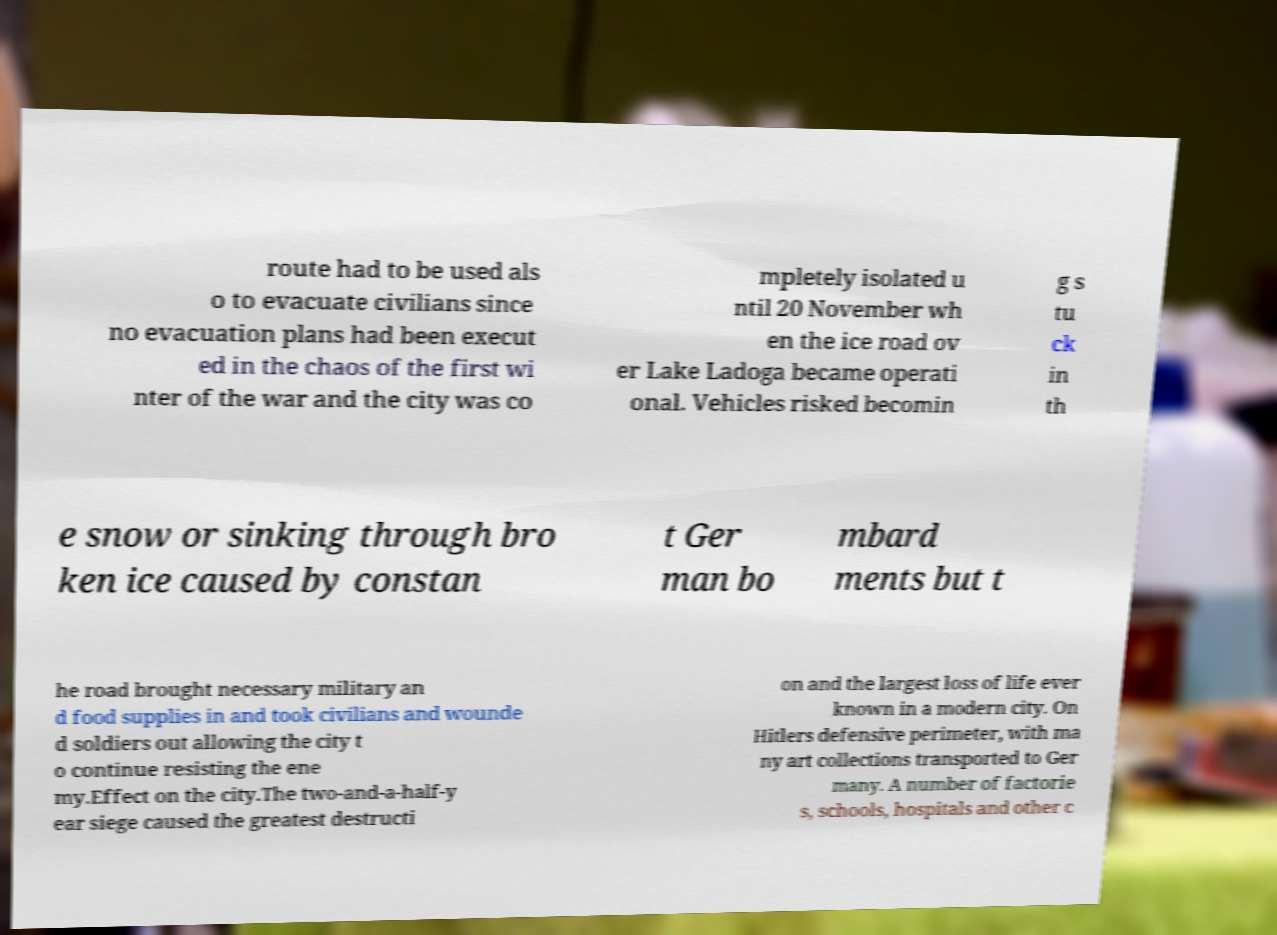Please identify and transcribe the text found in this image. route had to be used als o to evacuate civilians since no evacuation plans had been execut ed in the chaos of the first wi nter of the war and the city was co mpletely isolated u ntil 20 November wh en the ice road ov er Lake Ladoga became operati onal. Vehicles risked becomin g s tu ck in th e snow or sinking through bro ken ice caused by constan t Ger man bo mbard ments but t he road brought necessary military an d food supplies in and took civilians and wounde d soldiers out allowing the city t o continue resisting the ene my.Effect on the city.The two-and-a-half-y ear siege caused the greatest destructi on and the largest loss of life ever known in a modern city. On Hitlers defensive perimeter, with ma ny art collections transported to Ger many. A number of factorie s, schools, hospitals and other c 